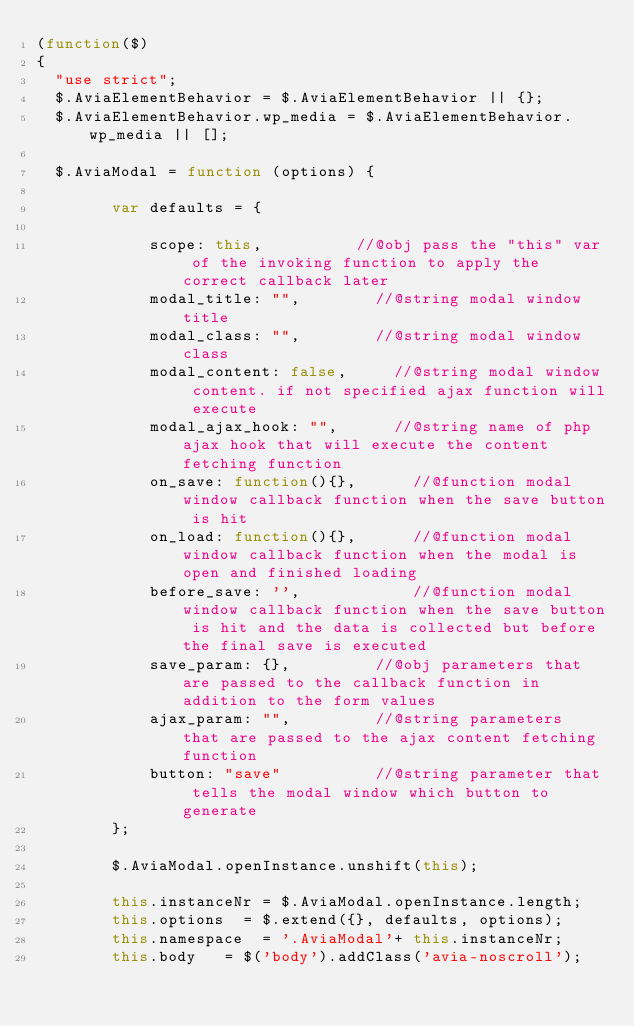<code> <loc_0><loc_0><loc_500><loc_500><_JavaScript_>(function($)
{
	"use strict";
	$.AviaElementBehavior = $.AviaElementBehavior || {};
	$.AviaElementBehavior.wp_media = $.AviaElementBehavior.wp_media || [];
	
 	$.AviaModal = function (options) {
        
        var defaults = {
        	
        		scope: this,					//@obj pass the "this" var of the invoking function to apply the correct callback later
        		modal_title: "",				//@string modal window title
        		modal_class: "",				//@string modal window class
        		modal_content: false,			//@string modal window content. if not specified ajax function will execute
        		modal_ajax_hook: "",			//@string name of php ajax hook that will execute the content fetching function
        		on_save: function(){},			//@function modal window callback function when the save button is hit
        		on_load: function(){},			//@function modal window callback function when the modal is open and finished loading
        		before_save: '',		        //@function modal window callback function when the save button is hit and the data is collected but before the final save is executed
        		save_param: {},					//@obj parameters that are passed to the callback function in addition to the form values
        		ajax_param: "",					//@string parameters that are passed to the ajax content fetching function
        		button: "save"					//@string parameter that tells the modal window which button to generate
        };
        
        $.AviaModal.openInstance.unshift(this); 
        
        this.instanceNr	= $.AviaModal.openInstance.length;
        this.options	= $.extend({}, defaults, options);
        this.namespace	= '.AviaModal'+ this.instanceNr;
        this.body		= $('body').addClass('avia-noscroll');</code> 